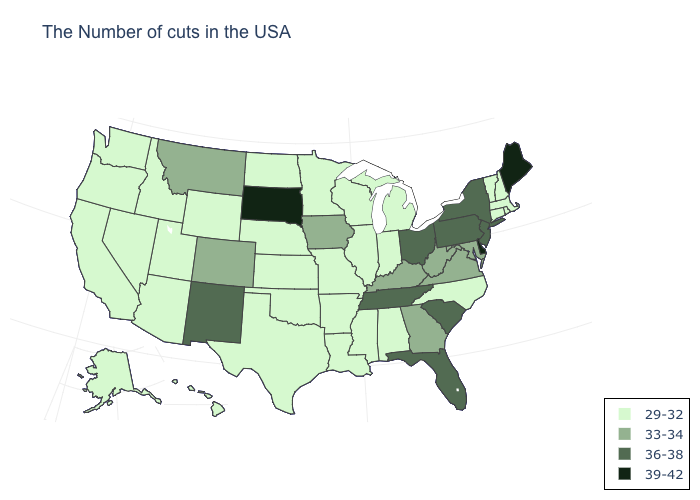Does Michigan have the same value as Connecticut?
Answer briefly. Yes. What is the value of New Jersey?
Answer briefly. 36-38. Name the states that have a value in the range 36-38?
Answer briefly. New York, New Jersey, Pennsylvania, South Carolina, Ohio, Florida, Tennessee, New Mexico. Among the states that border Kentucky , does Virginia have the lowest value?
Give a very brief answer. No. What is the lowest value in the MidWest?
Answer briefly. 29-32. Does Delaware have the highest value in the South?
Concise answer only. Yes. Name the states that have a value in the range 39-42?
Give a very brief answer. Maine, Delaware, South Dakota. Does Alaska have a lower value than Ohio?
Be succinct. Yes. Name the states that have a value in the range 39-42?
Write a very short answer. Maine, Delaware, South Dakota. Which states have the highest value in the USA?
Short answer required. Maine, Delaware, South Dakota. What is the value of South Carolina?
Write a very short answer. 36-38. What is the value of Maryland?
Write a very short answer. 33-34. What is the value of Michigan?
Concise answer only. 29-32. What is the value of Alabama?
Concise answer only. 29-32. What is the value of Oklahoma?
Give a very brief answer. 29-32. 